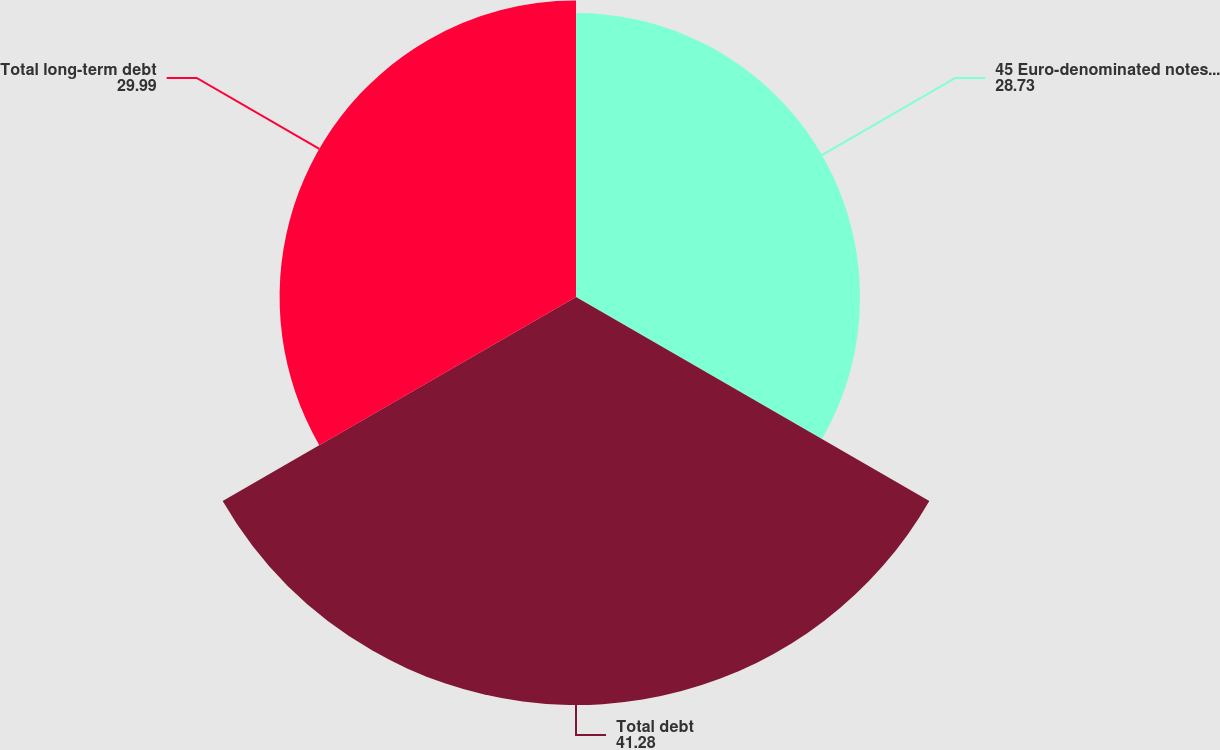<chart> <loc_0><loc_0><loc_500><loc_500><pie_chart><fcel>45 Euro-denominated notes due<fcel>Total debt<fcel>Total long-term debt<nl><fcel>28.73%<fcel>41.28%<fcel>29.99%<nl></chart> 